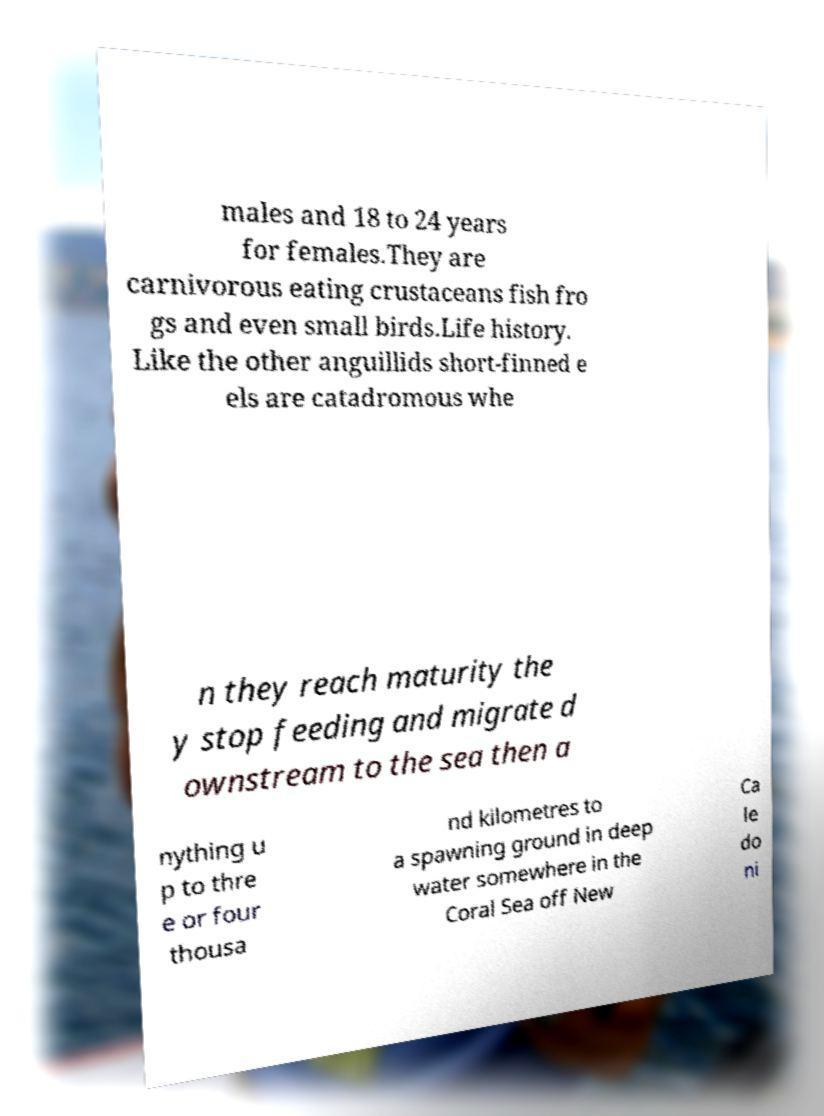What messages or text are displayed in this image? I need them in a readable, typed format. males and 18 to 24 years for females.They are carnivorous eating crustaceans fish fro gs and even small birds.Life history. Like the other anguillids short-finned e els are catadromous whe n they reach maturity the y stop feeding and migrate d ownstream to the sea then a nything u p to thre e or four thousa nd kilometres to a spawning ground in deep water somewhere in the Coral Sea off New Ca le do ni 